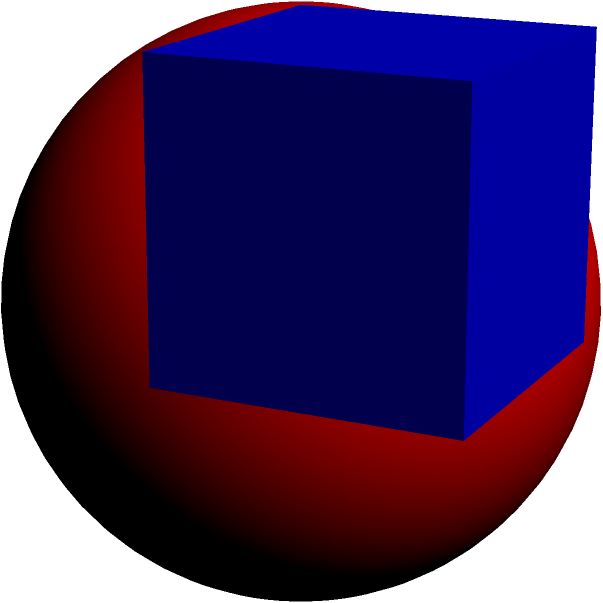A cube has a side length of 10 cm. What is the volume of the largest sphere that can be inscribed within this cube? To solve this problem, let's follow these steps:

1) The diameter of the inscribed sphere is equal to the side length of the cube. So, the radius of the sphere is half the side length of the cube.

   Radius of sphere = $\frac{1}{2} \times$ side length of cube
   $r = \frac{1}{2} \times 10 = 5$ cm

2) The volume of a sphere is given by the formula:
   $V = \frac{4}{3}\pi r^3$

3) Substituting the radius we found:
   $V = \frac{4}{3}\pi (5)^3$

4) Simplify:
   $V = \frac{4}{3}\pi \times 125$
   $V = \frac{500}{3}\pi$

5) Calculate the final value:
   $V \approx 523.6$ cm³

Therefore, the volume of the largest sphere that can be inscribed in the cube is approximately 523.6 cubic centimeters.
Answer: $\frac{500}{3}\pi$ cm³ or approximately 523.6 cm³ 